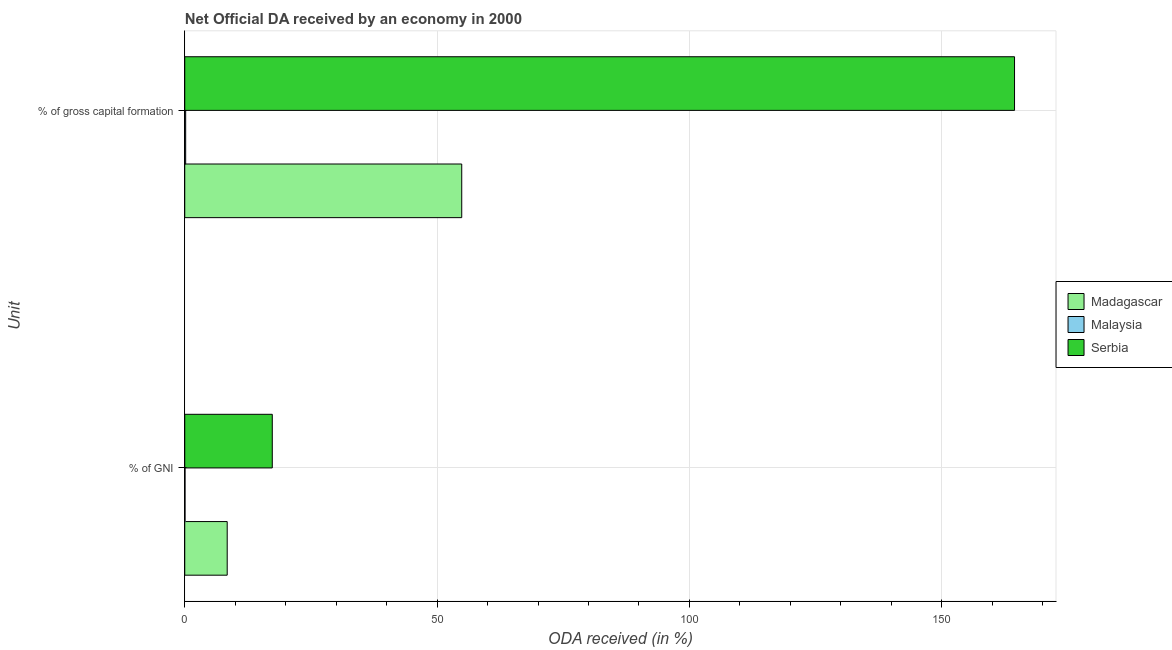How many groups of bars are there?
Provide a short and direct response. 2. Are the number of bars per tick equal to the number of legend labels?
Provide a succinct answer. Yes. How many bars are there on the 2nd tick from the top?
Ensure brevity in your answer.  3. How many bars are there on the 2nd tick from the bottom?
Your answer should be very brief. 3. What is the label of the 2nd group of bars from the top?
Offer a very short reply. % of GNI. What is the oda received as percentage of gni in Madagascar?
Offer a terse response. 8.41. Across all countries, what is the maximum oda received as percentage of gross capital formation?
Your response must be concise. 164.42. Across all countries, what is the minimum oda received as percentage of gni?
Give a very brief answer. 0.05. In which country was the oda received as percentage of gni maximum?
Provide a succinct answer. Serbia. In which country was the oda received as percentage of gni minimum?
Keep it short and to the point. Malaysia. What is the total oda received as percentage of gni in the graph?
Provide a short and direct response. 25.81. What is the difference between the oda received as percentage of gross capital formation in Madagascar and that in Serbia?
Your answer should be very brief. -109.54. What is the difference between the oda received as percentage of gni in Madagascar and the oda received as percentage of gross capital formation in Serbia?
Provide a short and direct response. -156.01. What is the average oda received as percentage of gross capital formation per country?
Ensure brevity in your answer.  73.16. What is the difference between the oda received as percentage of gni and oda received as percentage of gross capital formation in Malaysia?
Provide a short and direct response. -0.13. In how many countries, is the oda received as percentage of gni greater than 120 %?
Make the answer very short. 0. What is the ratio of the oda received as percentage of gross capital formation in Malaysia to that in Madagascar?
Ensure brevity in your answer.  0. What does the 3rd bar from the top in % of gross capital formation represents?
Ensure brevity in your answer.  Madagascar. What does the 3rd bar from the bottom in % of gross capital formation represents?
Offer a very short reply. Serbia. Are all the bars in the graph horizontal?
Offer a very short reply. Yes. What is the difference between two consecutive major ticks on the X-axis?
Give a very brief answer. 50. Are the values on the major ticks of X-axis written in scientific E-notation?
Your answer should be compact. No. Does the graph contain grids?
Ensure brevity in your answer.  Yes. Where does the legend appear in the graph?
Your answer should be very brief. Center right. What is the title of the graph?
Keep it short and to the point. Net Official DA received by an economy in 2000. What is the label or title of the X-axis?
Your response must be concise. ODA received (in %). What is the label or title of the Y-axis?
Provide a succinct answer. Unit. What is the ODA received (in %) of Madagascar in % of GNI?
Make the answer very short. 8.41. What is the ODA received (in %) in Malaysia in % of GNI?
Your answer should be compact. 0.05. What is the ODA received (in %) of Serbia in % of GNI?
Provide a short and direct response. 17.34. What is the ODA received (in %) in Madagascar in % of gross capital formation?
Offer a very short reply. 54.89. What is the ODA received (in %) in Malaysia in % of gross capital formation?
Provide a succinct answer. 0.18. What is the ODA received (in %) in Serbia in % of gross capital formation?
Give a very brief answer. 164.42. Across all Unit, what is the maximum ODA received (in %) of Madagascar?
Your answer should be compact. 54.89. Across all Unit, what is the maximum ODA received (in %) of Malaysia?
Offer a terse response. 0.18. Across all Unit, what is the maximum ODA received (in %) in Serbia?
Make the answer very short. 164.42. Across all Unit, what is the minimum ODA received (in %) of Madagascar?
Make the answer very short. 8.41. Across all Unit, what is the minimum ODA received (in %) of Malaysia?
Offer a very short reply. 0.05. Across all Unit, what is the minimum ODA received (in %) of Serbia?
Offer a terse response. 17.34. What is the total ODA received (in %) of Madagascar in the graph?
Keep it short and to the point. 63.3. What is the total ODA received (in %) of Malaysia in the graph?
Your answer should be compact. 0.23. What is the total ODA received (in %) of Serbia in the graph?
Give a very brief answer. 181.77. What is the difference between the ODA received (in %) of Madagascar in % of GNI and that in % of gross capital formation?
Offer a very short reply. -46.48. What is the difference between the ODA received (in %) in Malaysia in % of GNI and that in % of gross capital formation?
Keep it short and to the point. -0.13. What is the difference between the ODA received (in %) in Serbia in % of GNI and that in % of gross capital formation?
Provide a succinct answer. -147.08. What is the difference between the ODA received (in %) of Madagascar in % of GNI and the ODA received (in %) of Malaysia in % of gross capital formation?
Provide a succinct answer. 8.23. What is the difference between the ODA received (in %) of Madagascar in % of GNI and the ODA received (in %) of Serbia in % of gross capital formation?
Provide a short and direct response. -156.01. What is the difference between the ODA received (in %) of Malaysia in % of GNI and the ODA received (in %) of Serbia in % of gross capital formation?
Keep it short and to the point. -164.37. What is the average ODA received (in %) of Madagascar per Unit?
Provide a succinct answer. 31.65. What is the average ODA received (in %) in Malaysia per Unit?
Your answer should be very brief. 0.12. What is the average ODA received (in %) of Serbia per Unit?
Your response must be concise. 90.88. What is the difference between the ODA received (in %) of Madagascar and ODA received (in %) of Malaysia in % of GNI?
Your answer should be very brief. 8.36. What is the difference between the ODA received (in %) of Madagascar and ODA received (in %) of Serbia in % of GNI?
Your response must be concise. -8.93. What is the difference between the ODA received (in %) in Malaysia and ODA received (in %) in Serbia in % of GNI?
Give a very brief answer. -17.29. What is the difference between the ODA received (in %) in Madagascar and ODA received (in %) in Malaysia in % of gross capital formation?
Ensure brevity in your answer.  54.7. What is the difference between the ODA received (in %) of Madagascar and ODA received (in %) of Serbia in % of gross capital formation?
Your response must be concise. -109.54. What is the difference between the ODA received (in %) of Malaysia and ODA received (in %) of Serbia in % of gross capital formation?
Offer a terse response. -164.24. What is the ratio of the ODA received (in %) of Madagascar in % of GNI to that in % of gross capital formation?
Your answer should be very brief. 0.15. What is the ratio of the ODA received (in %) in Malaysia in % of GNI to that in % of gross capital formation?
Your response must be concise. 0.29. What is the ratio of the ODA received (in %) of Serbia in % of GNI to that in % of gross capital formation?
Make the answer very short. 0.11. What is the difference between the highest and the second highest ODA received (in %) in Madagascar?
Offer a terse response. 46.48. What is the difference between the highest and the second highest ODA received (in %) in Malaysia?
Ensure brevity in your answer.  0.13. What is the difference between the highest and the second highest ODA received (in %) of Serbia?
Provide a short and direct response. 147.08. What is the difference between the highest and the lowest ODA received (in %) of Madagascar?
Your response must be concise. 46.48. What is the difference between the highest and the lowest ODA received (in %) in Malaysia?
Offer a terse response. 0.13. What is the difference between the highest and the lowest ODA received (in %) in Serbia?
Your answer should be compact. 147.08. 